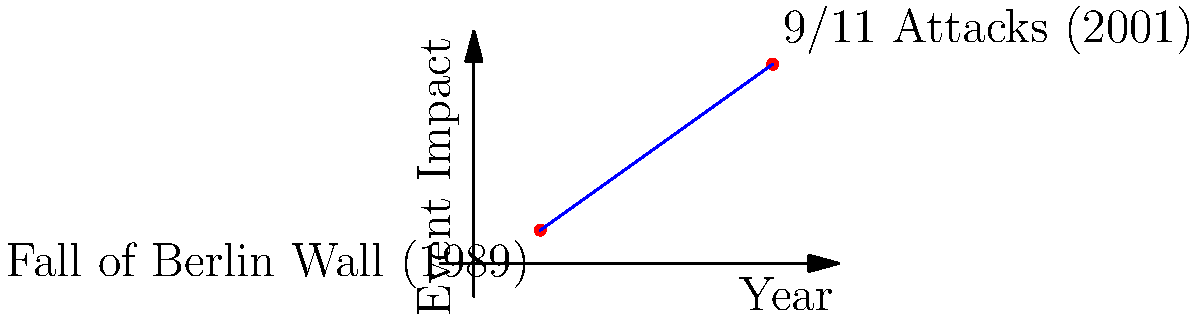In the timeline of significant international events, the Fall of the Berlin Wall in 1989 and the 9/11 Attacks in 2001 are represented as points (2,1) and (9,6) respectively on a coordinate plane. The x-axis represents the years since 1987, and the y-axis represents the event's impact on international relations on a scale of 0 to 7. Calculate the slope of the line connecting these two events. What does this slope indicate about the change in impact of global events during this period? To calculate the slope of the line connecting these two points, we'll use the slope formula:

$$ m = \frac{y_2 - y_1}{x_2 - x_1} $$

Where $(x_1, y_1)$ is the point representing the Fall of the Berlin Wall (2,1), and $(x_2, y_2)$ is the point representing the 9/11 Attacks (9,6).

Step 1: Identify the coordinates
$(x_1, y_1) = (2, 1)$
$(x_2, y_2) = (9, 6)$

Step 2: Apply the slope formula
$$ m = \frac{6 - 1}{9 - 2} = \frac{5}{7} \approx 0.714 $$

Step 3: Interpret the result
The slope is positive, indicating an upward trend in the impact of global events between 1989 and 2001. The value of approximately 0.714 means that for each year that passed (on average), the impact of global events increased by 0.714 units on our scale.

This slope suggests that over this 12-year period, there was a significant increase in the intensity and global impact of international events, culminating in the highly impactful 9/11 attacks.
Answer: $\frac{5}{7}$ or approximately 0.714, indicating an increasing trend in the impact of global events from 1989 to 2001. 